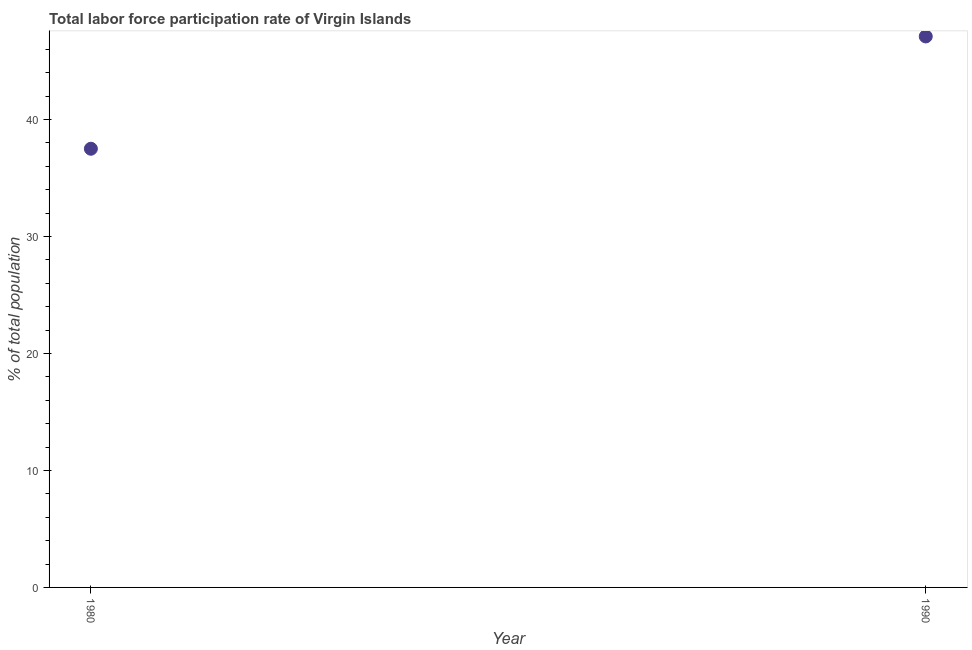What is the total labor force participation rate in 1980?
Provide a short and direct response. 37.5. Across all years, what is the maximum total labor force participation rate?
Give a very brief answer. 47.1. Across all years, what is the minimum total labor force participation rate?
Ensure brevity in your answer.  37.5. In which year was the total labor force participation rate maximum?
Your answer should be very brief. 1990. What is the sum of the total labor force participation rate?
Offer a very short reply. 84.6. What is the difference between the total labor force participation rate in 1980 and 1990?
Ensure brevity in your answer.  -9.6. What is the average total labor force participation rate per year?
Ensure brevity in your answer.  42.3. What is the median total labor force participation rate?
Give a very brief answer. 42.3. In how many years, is the total labor force participation rate greater than 6 %?
Make the answer very short. 2. Do a majority of the years between 1980 and 1990 (inclusive) have total labor force participation rate greater than 34 %?
Your answer should be compact. Yes. What is the ratio of the total labor force participation rate in 1980 to that in 1990?
Your answer should be compact. 0.8. Is the total labor force participation rate in 1980 less than that in 1990?
Make the answer very short. Yes. In how many years, is the total labor force participation rate greater than the average total labor force participation rate taken over all years?
Your response must be concise. 1. How many dotlines are there?
Provide a succinct answer. 1. Does the graph contain grids?
Your response must be concise. No. What is the title of the graph?
Ensure brevity in your answer.  Total labor force participation rate of Virgin Islands. What is the label or title of the Y-axis?
Your answer should be compact. % of total population. What is the % of total population in 1980?
Offer a very short reply. 37.5. What is the % of total population in 1990?
Make the answer very short. 47.1. What is the ratio of the % of total population in 1980 to that in 1990?
Make the answer very short. 0.8. 